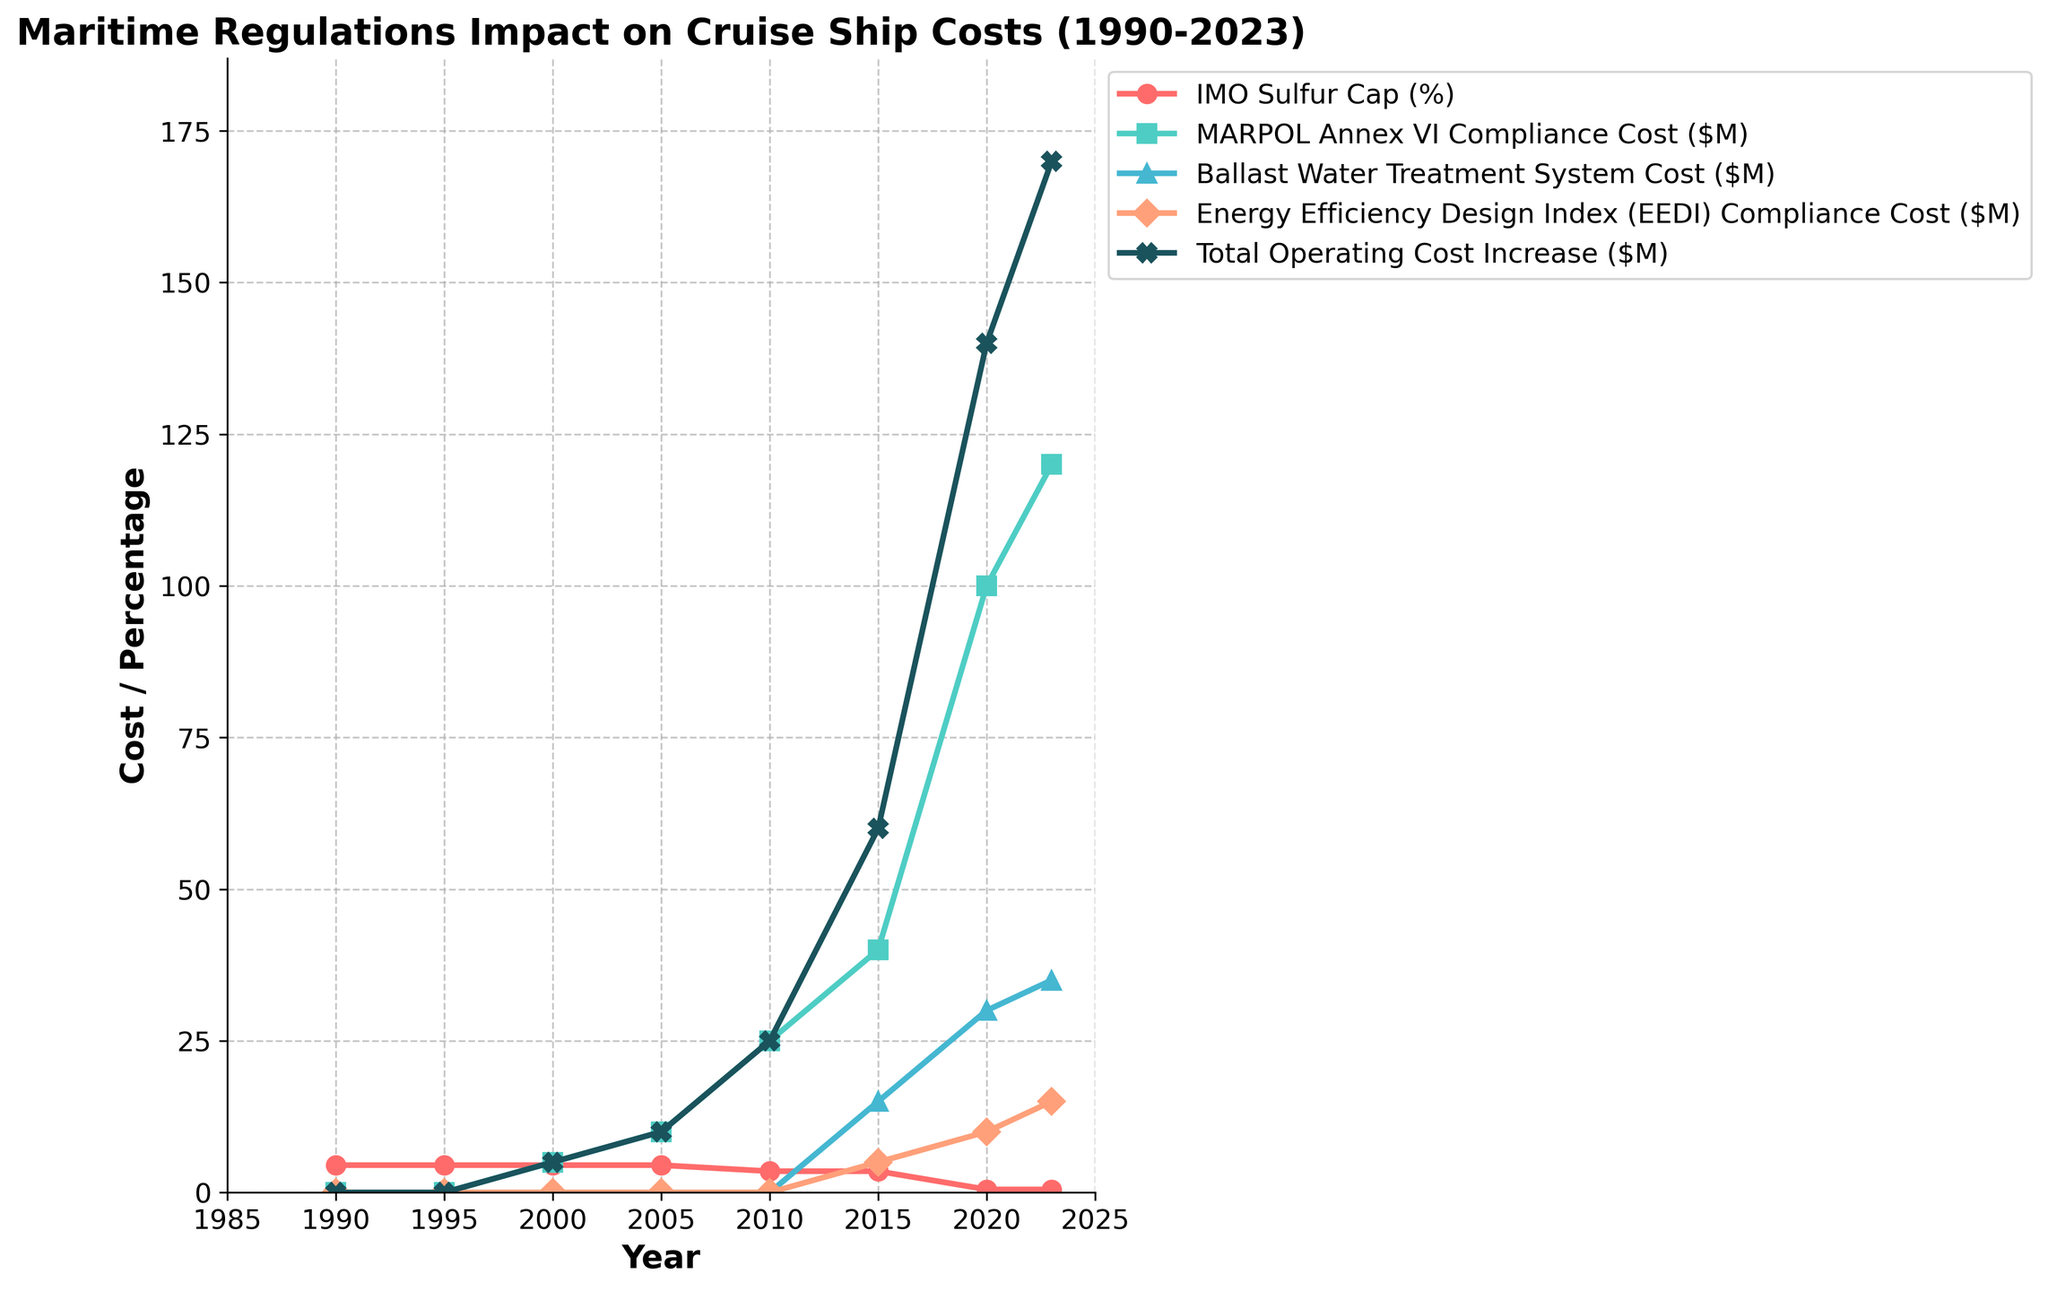What year did the IMO Sulfur Cap (%) have its most significant drop? The line for 'IMO Sulfur Cap (%)' shows a substantial drop between 2015 and 2020, from 3.5% to 0.5%. Therefore, the most significant drop occurred in 2020.
Answer: 2020 How much did the Total Operating Cost Increase ($M) grow from 2000 to 2023? The Total Operating Cost Increased from $5M in 2000 to $170M in 2023. The growth can be calculated as $170M - $5M = $165M.
Answer: $165M Compare the Ballast Water Treatment System Cost ($M) between 2015 and 2020. Which year had higher costs? The Ballast Water Treatment System Cost was $15M in 2015 and increased to $30M in 2020. Therefore, 2020 had higher costs.
Answer: 2020 What is the trend in MARPOL Annex VI Compliance Cost ($M) from 1990 to 2023? The line for MARPOL Annex VI Compliance Cost ($M) starts at $0M in 1990, then gradually increases to $5M in 2000, $10M in 2005, $25M in 2010, and subsequently rises more sharply to $120M by 2023. The overall trend is an increasing cost over time.
Answer: Increasing What visual attribute is used to differentiate the Energy Efficiency Design Index (EEDI) Compliance Cost ($M) line from others? The 'Energy Efficiency Design Index (EEDI) Compliance Cost ($M)' line is differentiated by using a light orange color with a diamond-shaped marker.
Answer: Light orange color with a diamond-shaped marker What can you infer about the impact of international maritime regulations on cruise ship operating costs over the years? Total Operating Cost Increase ($M) remained relatively low around $0-$10M till 2005 but saw a steady rise starting from 2010 with incremental increases in MARPOL Annex VI, Ballast Water Treatment, and EEDI Compliance costs contributing to a substantial total increase to $170M by 2023. This suggests that the cumulative burden of complying with multiple maritime regulations has significantly increased operating costs over the years.
Answer: Significant increase in costs due to regulations over the years 